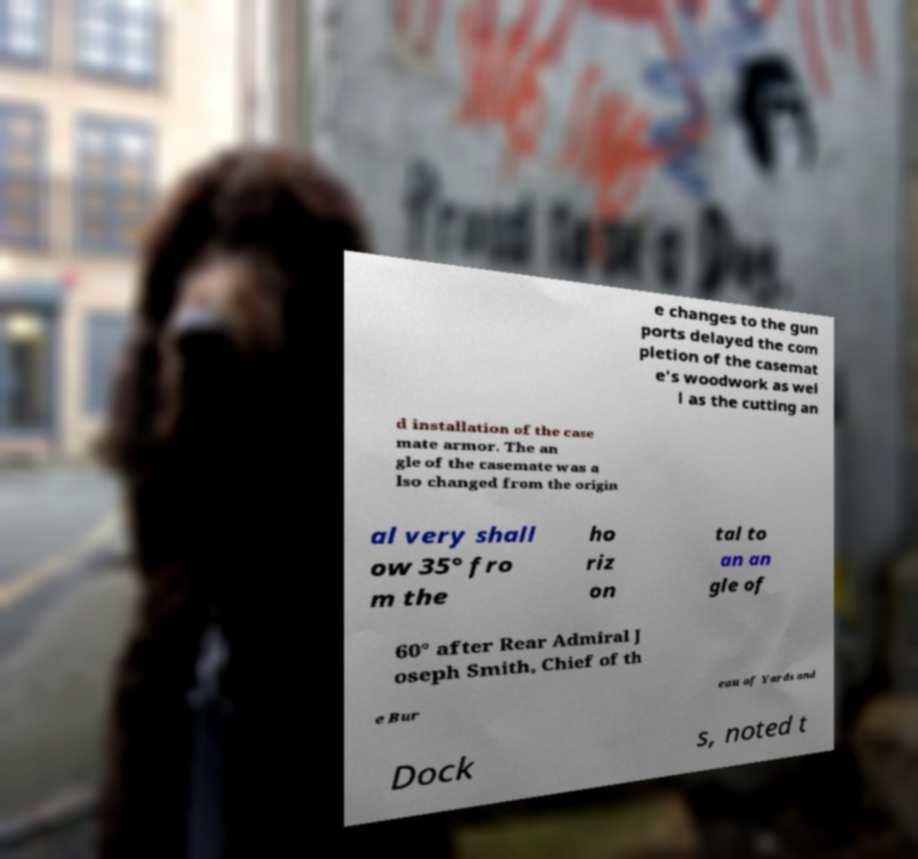Can you read and provide the text displayed in the image?This photo seems to have some interesting text. Can you extract and type it out for me? e changes to the gun ports delayed the com pletion of the casemat e's woodwork as wel l as the cutting an d installation of the case mate armor. The an gle of the casemate was a lso changed from the origin al very shall ow 35° fro m the ho riz on tal to an an gle of 60° after Rear Admiral J oseph Smith, Chief of th e Bur eau of Yards and Dock s, noted t 